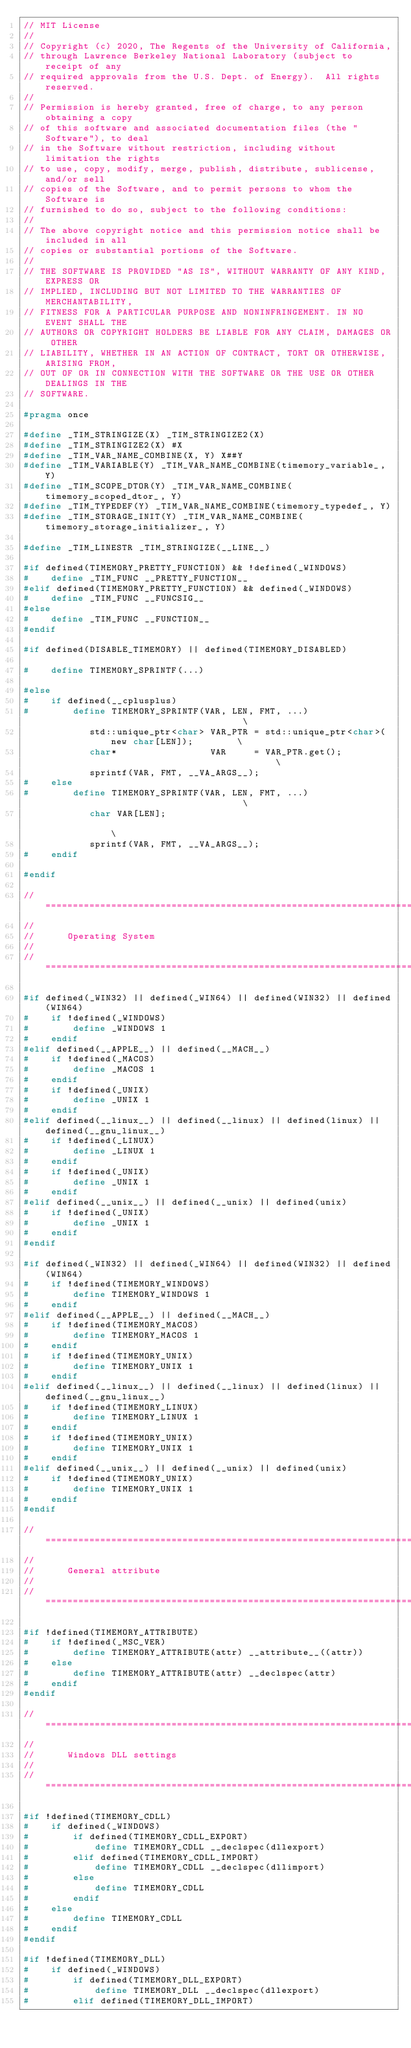<code> <loc_0><loc_0><loc_500><loc_500><_C_>// MIT License
//
// Copyright (c) 2020, The Regents of the University of California,
// through Lawrence Berkeley National Laboratory (subject to receipt of any
// required approvals from the U.S. Dept. of Energy).  All rights reserved.
//
// Permission is hereby granted, free of charge, to any person obtaining a copy
// of this software and associated documentation files (the "Software"), to deal
// in the Software without restriction, including without limitation the rights
// to use, copy, modify, merge, publish, distribute, sublicense, and/or sell
// copies of the Software, and to permit persons to whom the Software is
// furnished to do so, subject to the following conditions:
//
// The above copyright notice and this permission notice shall be included in all
// copies or substantial portions of the Software.
//
// THE SOFTWARE IS PROVIDED "AS IS", WITHOUT WARRANTY OF ANY KIND, EXPRESS OR
// IMPLIED, INCLUDING BUT NOT LIMITED TO THE WARRANTIES OF MERCHANTABILITY,
// FITNESS FOR A PARTICULAR PURPOSE AND NONINFRINGEMENT. IN NO EVENT SHALL THE
// AUTHORS OR COPYRIGHT HOLDERS BE LIABLE FOR ANY CLAIM, DAMAGES OR OTHER
// LIABILITY, WHETHER IN AN ACTION OF CONTRACT, TORT OR OTHERWISE, ARISING FROM,
// OUT OF OR IN CONNECTION WITH THE SOFTWARE OR THE USE OR OTHER DEALINGS IN THE
// SOFTWARE.

#pragma once

#define _TIM_STRINGIZE(X) _TIM_STRINGIZE2(X)
#define _TIM_STRINGIZE2(X) #X
#define _TIM_VAR_NAME_COMBINE(X, Y) X##Y
#define _TIM_VARIABLE(Y) _TIM_VAR_NAME_COMBINE(timemory_variable_, Y)
#define _TIM_SCOPE_DTOR(Y) _TIM_VAR_NAME_COMBINE(timemory_scoped_dtor_, Y)
#define _TIM_TYPEDEF(Y) _TIM_VAR_NAME_COMBINE(timemory_typedef_, Y)
#define _TIM_STORAGE_INIT(Y) _TIM_VAR_NAME_COMBINE(timemory_storage_initializer_, Y)

#define _TIM_LINESTR _TIM_STRINGIZE(__LINE__)

#if defined(TIMEMORY_PRETTY_FUNCTION) && !defined(_WINDOWS)
#    define _TIM_FUNC __PRETTY_FUNCTION__
#elif defined(TIMEMORY_PRETTY_FUNCTION) && defined(_WINDOWS)
#    define _TIM_FUNC __FUNCSIG__
#else
#    define _TIM_FUNC __FUNCTION__
#endif

#if defined(DISABLE_TIMEMORY) || defined(TIMEMORY_DISABLED)

#    define TIMEMORY_SPRINTF(...)

#else
#    if defined(__cplusplus)
#        define TIMEMORY_SPRINTF(VAR, LEN, FMT, ...)                                     \
            std::unique_ptr<char> VAR_PTR = std::unique_ptr<char>(new char[LEN]);        \
            char*                 VAR     = VAR_PTR.get();                               \
            sprintf(VAR, FMT, __VA_ARGS__);
#    else
#        define TIMEMORY_SPRINTF(VAR, LEN, FMT, ...)                                     \
            char VAR[LEN];                                                               \
            sprintf(VAR, FMT, __VA_ARGS__);
#    endif

#endif

//======================================================================================//
//
//      Operating System
//
//======================================================================================//

#if defined(_WIN32) || defined(_WIN64) || defined(WIN32) || defined(WIN64)
#    if !defined(_WINDOWS)
#        define _WINDOWS 1
#    endif
#elif defined(__APPLE__) || defined(__MACH__)
#    if !defined(_MACOS)
#        define _MACOS 1
#    endif
#    if !defined(_UNIX)
#        define _UNIX 1
#    endif
#elif defined(__linux__) || defined(__linux) || defined(linux) || defined(__gnu_linux__)
#    if !defined(_LINUX)
#        define _LINUX 1
#    endif
#    if !defined(_UNIX)
#        define _UNIX 1
#    endif
#elif defined(__unix__) || defined(__unix) || defined(unix)
#    if !defined(_UNIX)
#        define _UNIX 1
#    endif
#endif

#if defined(_WIN32) || defined(_WIN64) || defined(WIN32) || defined(WIN64)
#    if !defined(TIMEMORY_WINDOWS)
#        define TIMEMORY_WINDOWS 1
#    endif
#elif defined(__APPLE__) || defined(__MACH__)
#    if !defined(TIMEMORY_MACOS)
#        define TIMEMORY_MACOS 1
#    endif
#    if !defined(TIMEMORY_UNIX)
#        define TIMEMORY_UNIX 1
#    endif
#elif defined(__linux__) || defined(__linux) || defined(linux) || defined(__gnu_linux__)
#    if !defined(TIMEMORY_LINUX)
#        define TIMEMORY_LINUX 1
#    endif
#    if !defined(TIMEMORY_UNIX)
#        define TIMEMORY_UNIX 1
#    endif
#elif defined(__unix__) || defined(__unix) || defined(unix)
#    if !defined(TIMEMORY_UNIX)
#        define TIMEMORY_UNIX 1
#    endif
#endif

//======================================================================================//
//
//      General attribute
//
//======================================================================================//

#if !defined(TIMEMORY_ATTRIBUTE)
#    if !defined(_MSC_VER)
#        define TIMEMORY_ATTRIBUTE(attr) __attribute__((attr))
#    else
#        define TIMEMORY_ATTRIBUTE(attr) __declspec(attr)
#    endif
#endif

//======================================================================================//
//
//      Windows DLL settings
//
//======================================================================================//

#if !defined(TIMEMORY_CDLL)
#    if defined(_WINDOWS)
#        if defined(TIMEMORY_CDLL_EXPORT)
#            define TIMEMORY_CDLL __declspec(dllexport)
#        elif defined(TIMEMORY_CDLL_IMPORT)
#            define TIMEMORY_CDLL __declspec(dllimport)
#        else
#            define TIMEMORY_CDLL
#        endif
#    else
#        define TIMEMORY_CDLL
#    endif
#endif

#if !defined(TIMEMORY_DLL)
#    if defined(_WINDOWS)
#        if defined(TIMEMORY_DLL_EXPORT)
#            define TIMEMORY_DLL __declspec(dllexport)
#        elif defined(TIMEMORY_DLL_IMPORT)</code> 